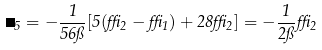Convert formula to latex. <formula><loc_0><loc_0><loc_500><loc_500>\Delta _ { 5 } = - \frac { 1 } { 5 6 \pi } [ 5 ( \delta _ { 2 } - \delta _ { 1 } ) + 2 8 \delta _ { 2 } ] = - \frac { 1 } { 2 \pi } \delta _ { 2 }</formula> 